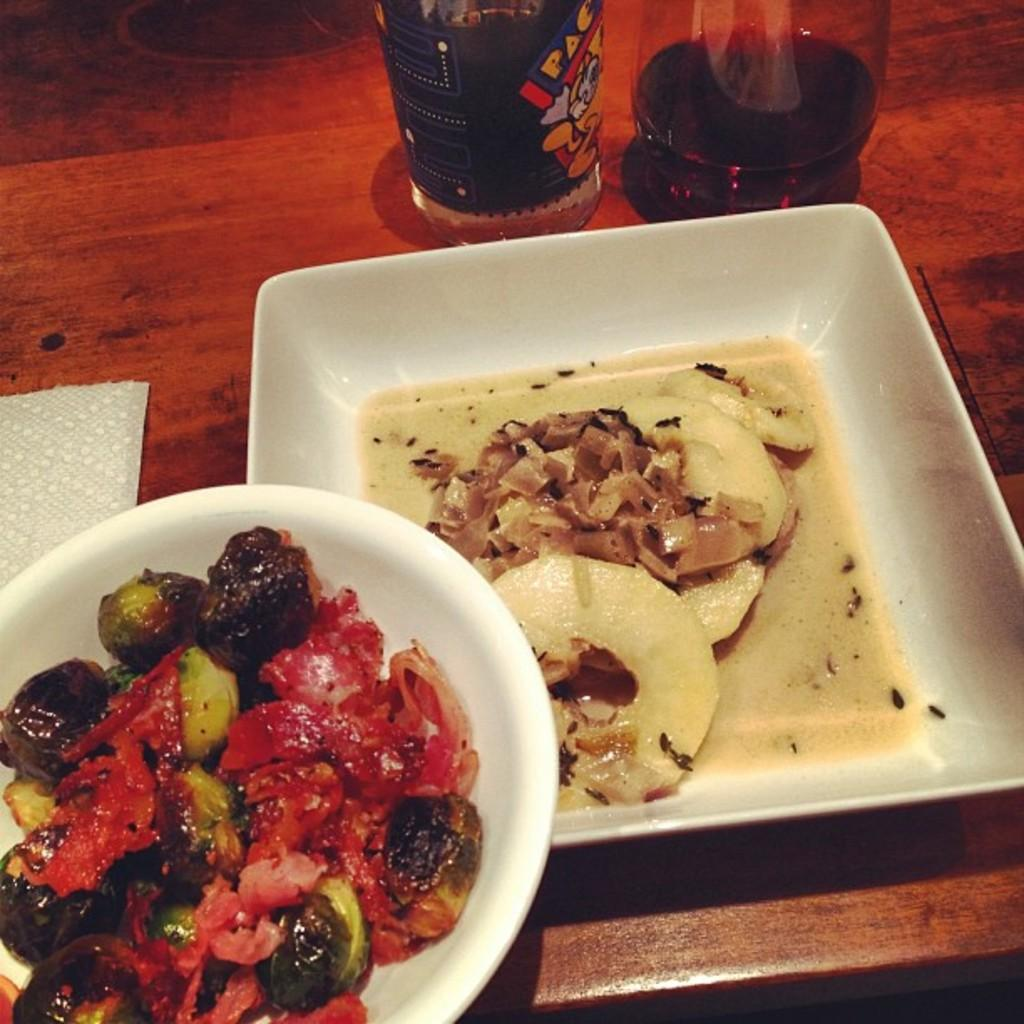What type of surface is visible in the image? There is a wooden surface in the image. What objects are placed on the wooden surface? There are plates and glasses on the wooden surface. What is on one of the plates? There is food on one of the plates. What can be used for wiping or blowing one's nose in the image? There is a tissue paper in the image. What theory is the duck discussing with the glasses in the image? There is no duck present in the image, so it cannot be discussing any theories with the glasses. 